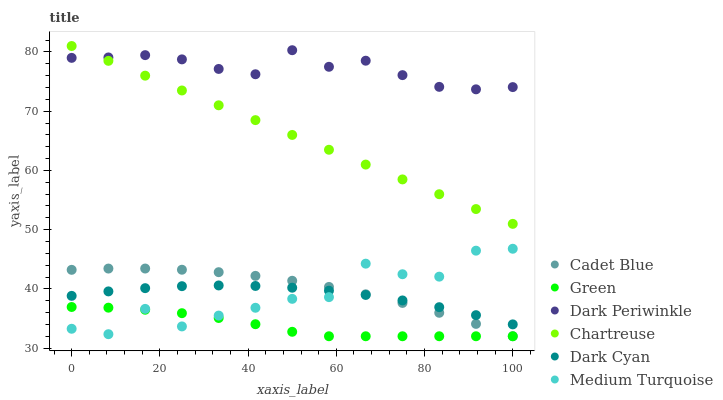Does Green have the minimum area under the curve?
Answer yes or no. Yes. Does Dark Periwinkle have the maximum area under the curve?
Answer yes or no. Yes. Does Chartreuse have the minimum area under the curve?
Answer yes or no. No. Does Chartreuse have the maximum area under the curve?
Answer yes or no. No. Is Chartreuse the smoothest?
Answer yes or no. Yes. Is Medium Turquoise the roughest?
Answer yes or no. Yes. Is Green the smoothest?
Answer yes or no. No. Is Green the roughest?
Answer yes or no. No. Does Green have the lowest value?
Answer yes or no. Yes. Does Chartreuse have the lowest value?
Answer yes or no. No. Does Chartreuse have the highest value?
Answer yes or no. Yes. Does Green have the highest value?
Answer yes or no. No. Is Medium Turquoise less than Dark Periwinkle?
Answer yes or no. Yes. Is Dark Periwinkle greater than Green?
Answer yes or no. Yes. Does Cadet Blue intersect Medium Turquoise?
Answer yes or no. Yes. Is Cadet Blue less than Medium Turquoise?
Answer yes or no. No. Is Cadet Blue greater than Medium Turquoise?
Answer yes or no. No. Does Medium Turquoise intersect Dark Periwinkle?
Answer yes or no. No. 